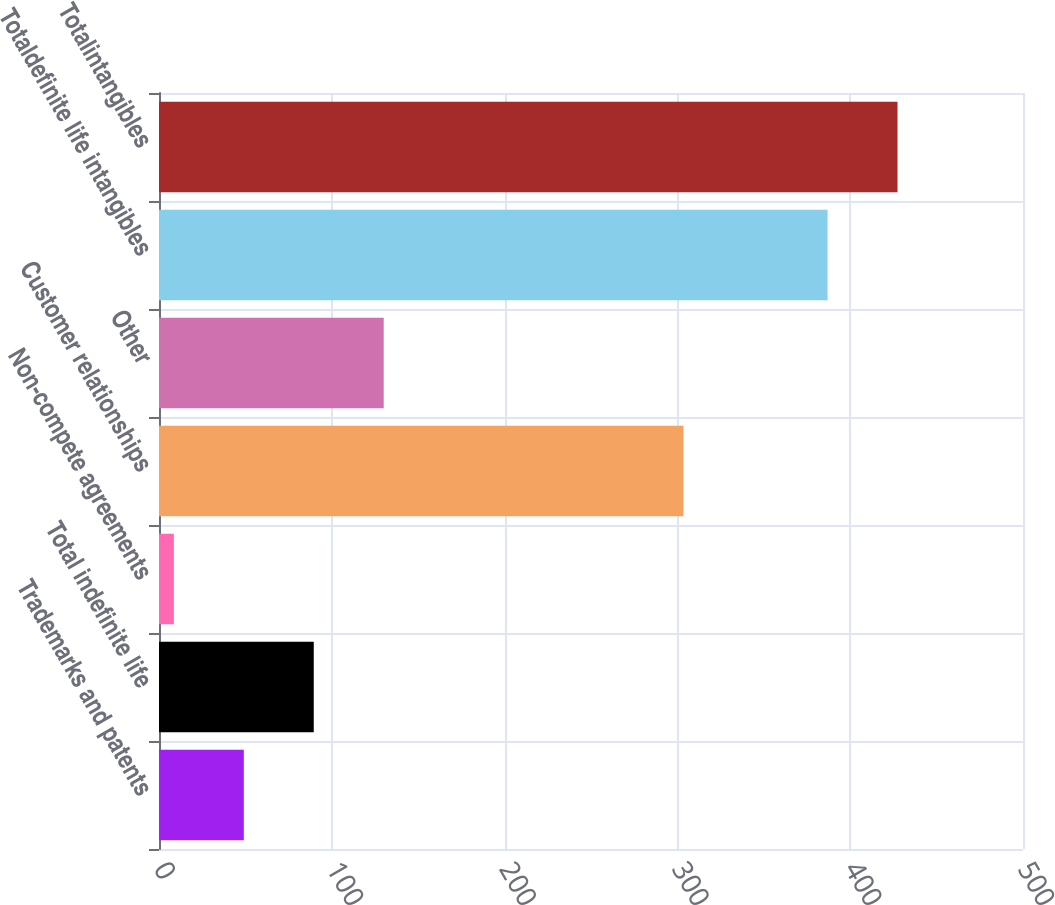Convert chart to OTSL. <chart><loc_0><loc_0><loc_500><loc_500><bar_chart><fcel>Trademarks and patents<fcel>Total indefinite life<fcel>Non-compete agreements<fcel>Customer relationships<fcel>Other<fcel>Totaldefinite life intangibles<fcel>Totalintangibles<nl><fcel>49.08<fcel>89.56<fcel>8.6<fcel>303.5<fcel>130.04<fcel>386.9<fcel>427.38<nl></chart> 